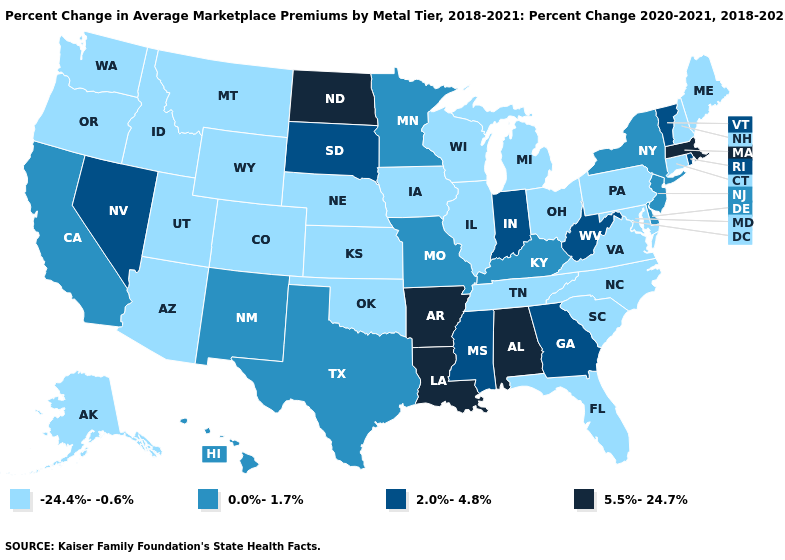Does West Virginia have the lowest value in the South?
Answer briefly. No. Which states have the lowest value in the USA?
Give a very brief answer. Alaska, Arizona, Colorado, Connecticut, Florida, Idaho, Illinois, Iowa, Kansas, Maine, Maryland, Michigan, Montana, Nebraska, New Hampshire, North Carolina, Ohio, Oklahoma, Oregon, Pennsylvania, South Carolina, Tennessee, Utah, Virginia, Washington, Wisconsin, Wyoming. Does the map have missing data?
Give a very brief answer. No. Name the states that have a value in the range 5.5%-24.7%?
Quick response, please. Alabama, Arkansas, Louisiana, Massachusetts, North Dakota. Name the states that have a value in the range 0.0%-1.7%?
Keep it brief. California, Delaware, Hawaii, Kentucky, Minnesota, Missouri, New Jersey, New Mexico, New York, Texas. What is the value of Colorado?
Write a very short answer. -24.4%--0.6%. What is the value of Wisconsin?
Give a very brief answer. -24.4%--0.6%. Which states have the highest value in the USA?
Be succinct. Alabama, Arkansas, Louisiana, Massachusetts, North Dakota. What is the value of Connecticut?
Keep it brief. -24.4%--0.6%. Does Kansas have the same value as Georgia?
Keep it brief. No. What is the highest value in the USA?
Answer briefly. 5.5%-24.7%. Does South Dakota have a higher value than Maine?
Concise answer only. Yes. What is the value of Colorado?
Give a very brief answer. -24.4%--0.6%. Is the legend a continuous bar?
Give a very brief answer. No. Which states have the highest value in the USA?
Be succinct. Alabama, Arkansas, Louisiana, Massachusetts, North Dakota. 